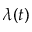<formula> <loc_0><loc_0><loc_500><loc_500>\lambda ( t )</formula> 